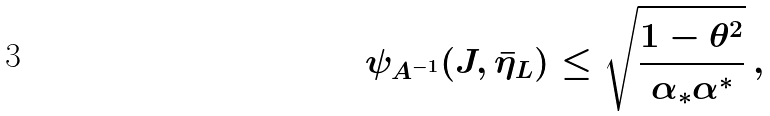<formula> <loc_0><loc_0><loc_500><loc_500>\psi _ { A ^ { - 1 } } ( J , \bar { \eta } _ { L } ) \leq \sqrt { \frac { 1 - \theta ^ { 2 } } { \alpha _ { * } \alpha ^ { * } } } \, ,</formula> 